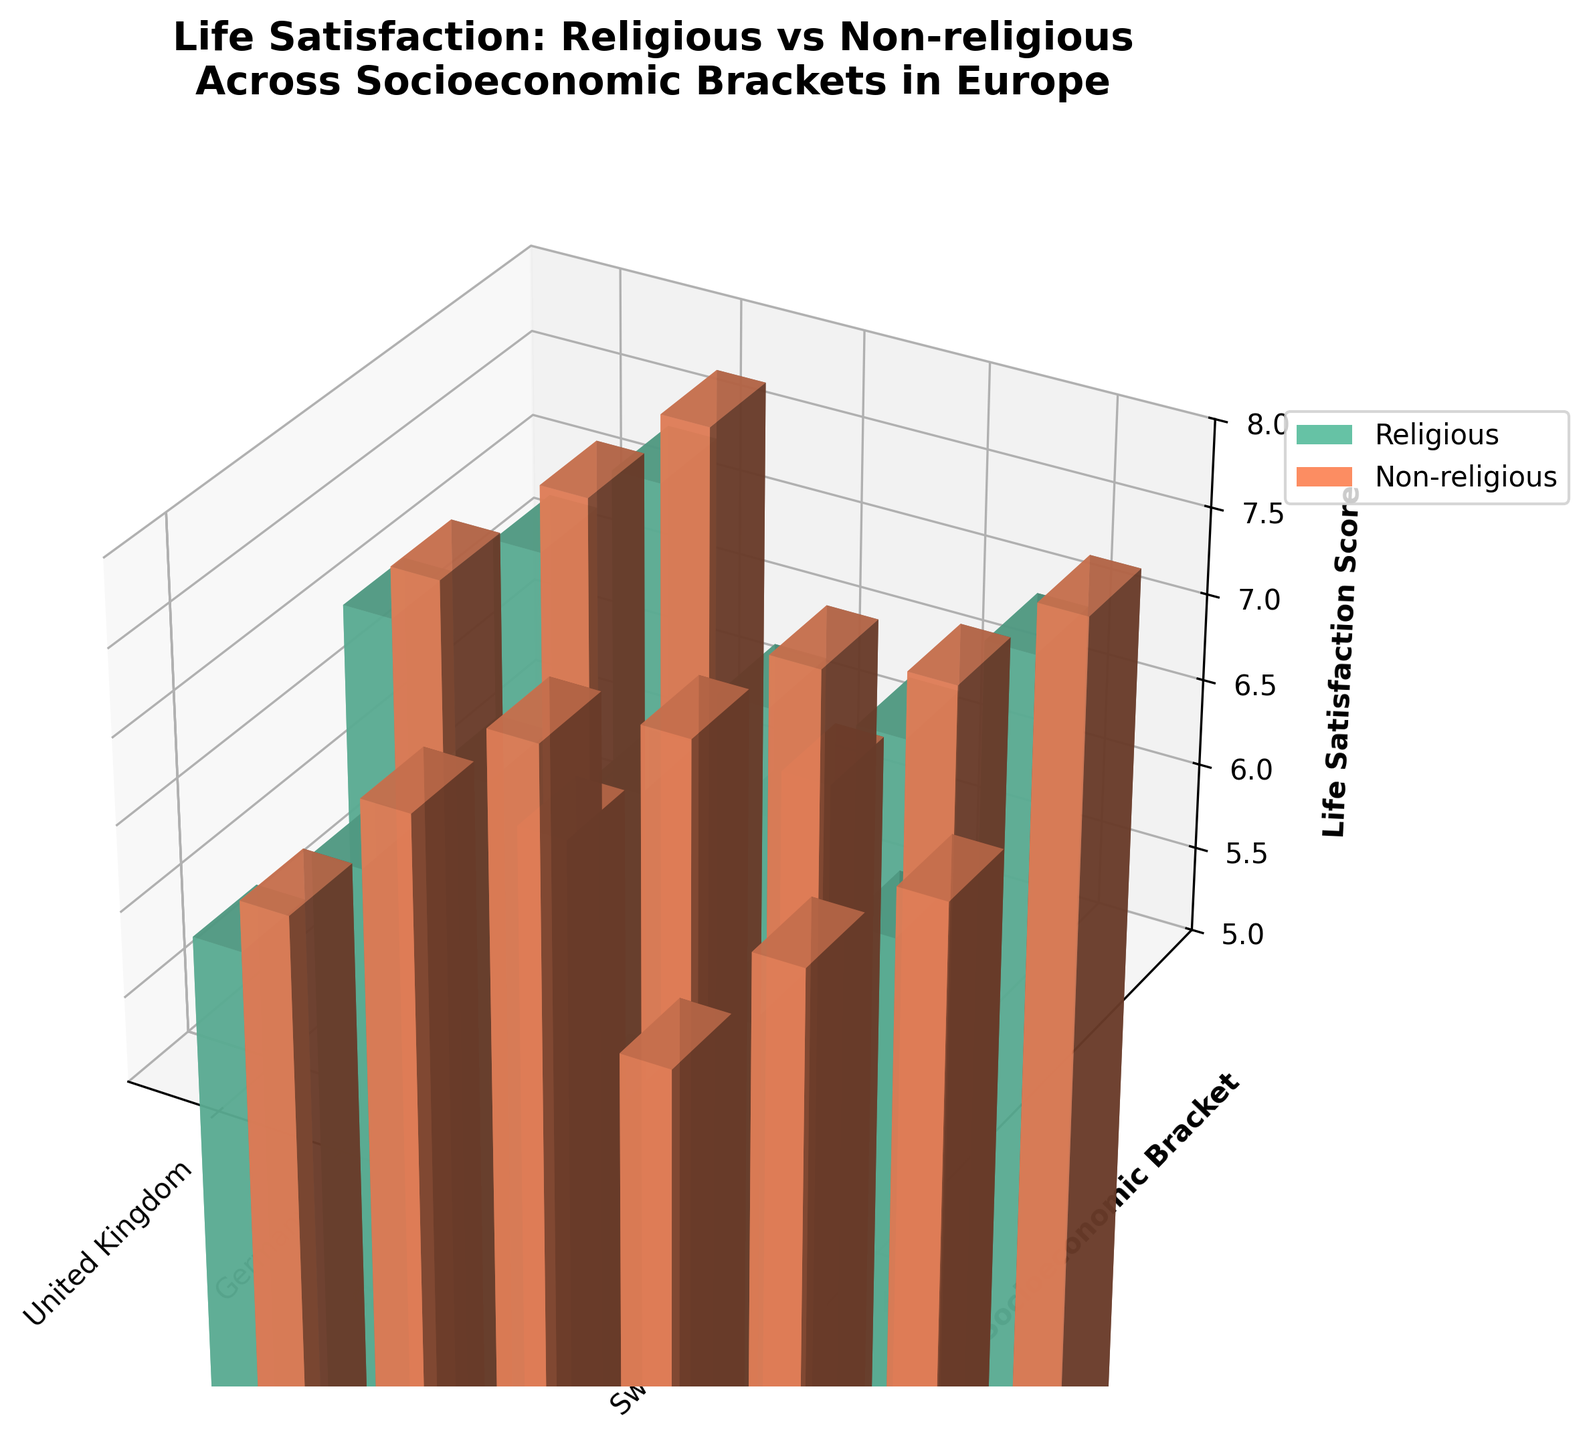What is the title of the plot? The title is located at the top of the plot and usually describes what the plot is about. In this case, it reads "Life Satisfaction: Religious vs Non-religious Across Socioeconomic Brackets in Europe".
Answer: Life Satisfaction: Religious vs Non-religious Across Socioeconomic Brackets in Europe What are the labels of the x and y axes? The x and y axis labels are displayed along the respective axes. The x-axis label is "Country" and the y-axis label is "Socioeconomic Bracket".
Answer: Country and Socioeconomic Bracket Which country shows the highest life satisfaction score among non-religious individuals in the high socioeconomic bracket? To find this, locate the bars corresponding to each country, focusing on the non-religious and high socioeconomic bracket data. Identify the tallest bar among them. For Sweden, the score is 7.7.
Answer: Sweden How does life satisfaction in the middle socioeconomic bracket compare between religious and non-religious individuals in Germany? To answer this, compare the height of the bars for the middle socioeconomic bracket in Germany between religious and non-religious individuals. The non-religious score is 6.8, while the religious score is 6.4. Non-religious individuals have higher life satisfaction.
Answer: Non-religious individuals have higher life satisfaction What is the overall trend in life satisfaction across different socioeconomic brackets for religious individuals in the United Kingdom? Evaluate the bars for religious individuals in the UK across different socioeconomic brackets. Life satisfaction increases from 5.8 in the low bracket to 6.5 in the middle bracket and 7.2 in the high bracket. Life satisfaction generally increases with the socioeconomic bracket.
Answer: Increases with socioeconomic bracket Which group has the lowest life satisfaction score in France? Locate the bars for France and identify both religious and non-religious groups across socioeconomic brackets. The score of 5.6 for religious individuals in the low socioeconomic bracket is the lowest.
Answer: Religious individuals in the low socioeconomic bracket Are non-religious individuals consistently more satisfied than religious individuals across all socioeconomic brackets in Sweden? Compare the heights of the bars for non-religious versus religious individuals in each socioeconomic bracket in Sweden. Non-religious individuals have higher scores in all brackets: 6.3 (low), 7.1 (middle), 7.7 (high) compared to religious scores: 6.0 (low), 6.7 (middle), 7.3 (high).
Answer: Yes What is the life satisfaction difference between religious and non-religious individuals in the high socioeconomic bracket in Italy? Subtract the life satisfaction score of religious individuals (6.9) from that of non-religious individuals (7.2) in the high socioeconomic bracket in Italy. The difference is 7.2 - 6.9 = 0.3.
Answer: 0.3 Which country has the smallest gap in life satisfaction between religious and non-religious individuals in the middle socioeconomic bracket? Evaluate the differences in scores for religious and non-religious individuals in the middle bracket for each country. The smallest difference is in the UK with less than 0.4 (6.9 - 6.5). The other countries show larger differences.
Answer: United Kingdom 